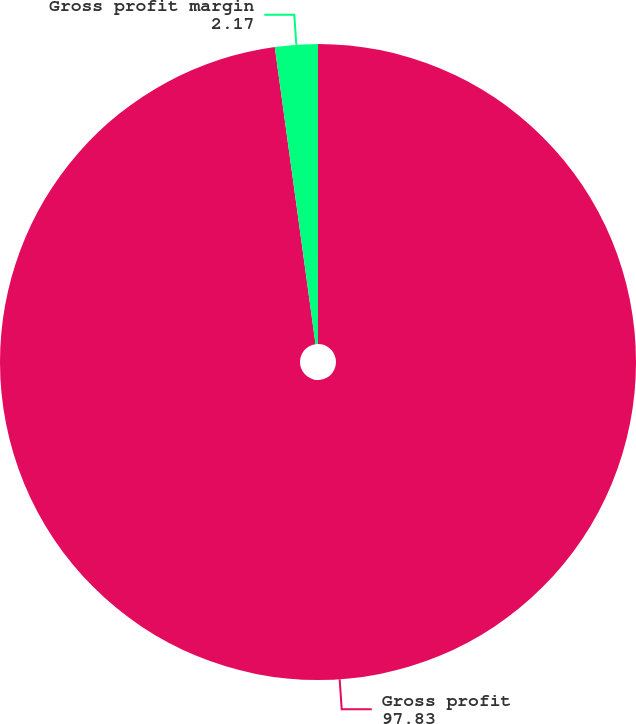<chart> <loc_0><loc_0><loc_500><loc_500><pie_chart><fcel>Gross profit<fcel>Gross profit margin<nl><fcel>97.83%<fcel>2.17%<nl></chart> 